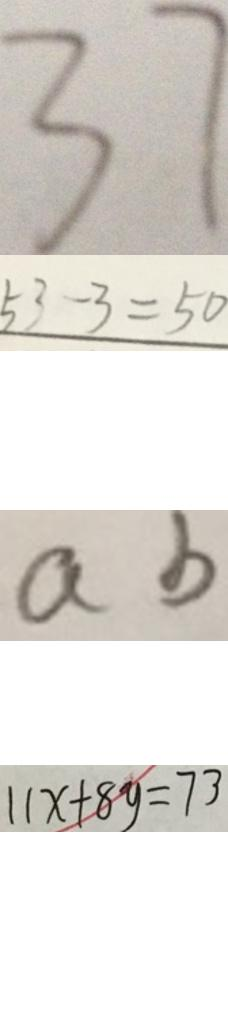<formula> <loc_0><loc_0><loc_500><loc_500>3 7 
 5 3 - 3 = 5 0 
 a b 
 1 1 x + 8 y = 7 3</formula> 